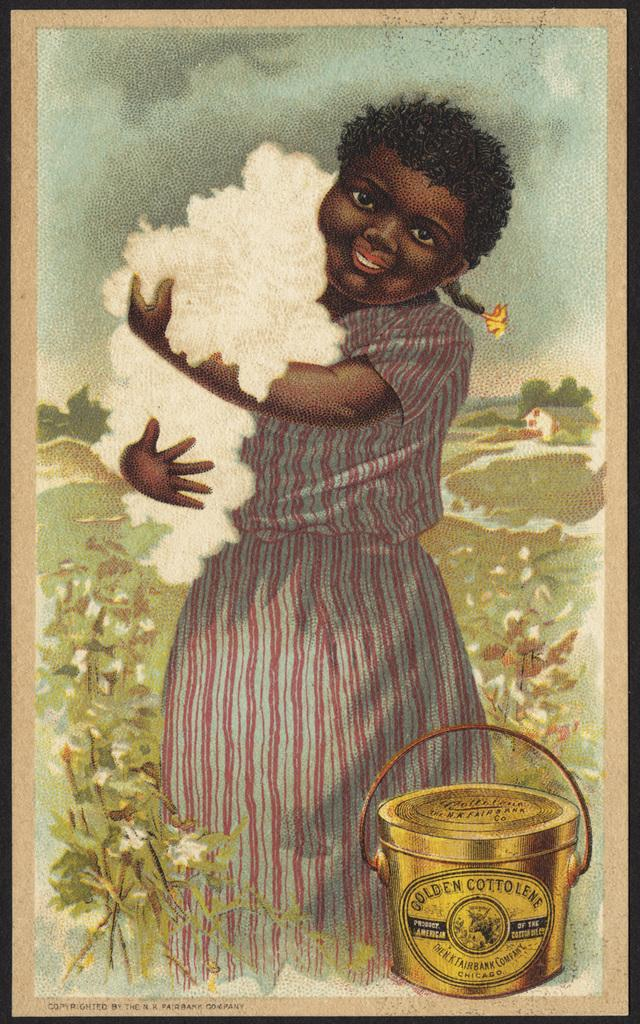<image>
Give a short and clear explanation of the subsequent image. A gold bucket with golden cottolene, product of America. 